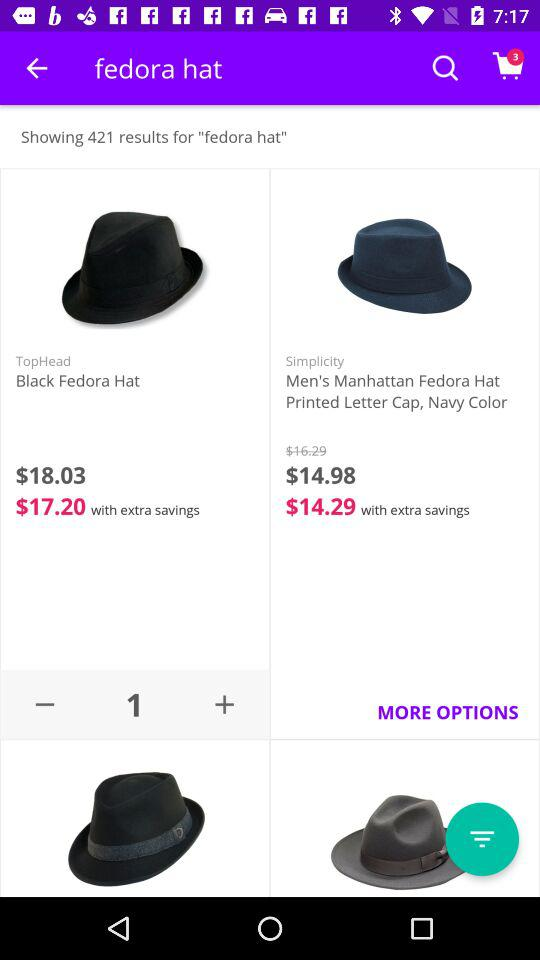What is the price of the "Black Fedora Hat" with extra savings? The price of the "Black Fedora Hat" with extra savings is $17.20. 